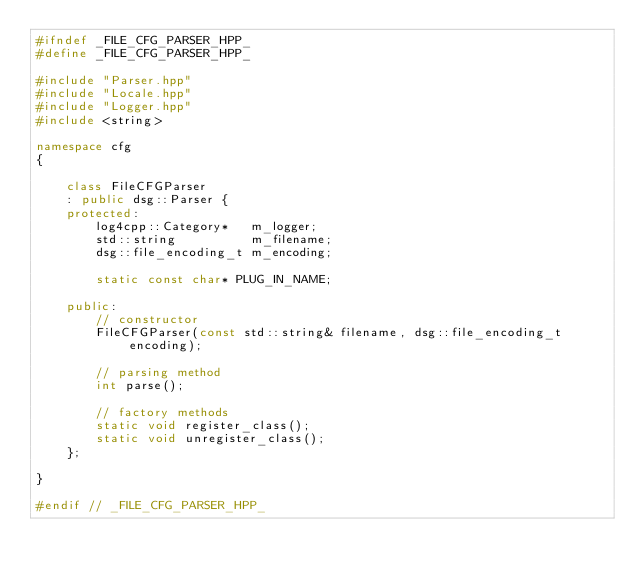<code> <loc_0><loc_0><loc_500><loc_500><_C++_>#ifndef _FILE_CFG_PARSER_HPP_
#define _FILE_CFG_PARSER_HPP_

#include "Parser.hpp"
#include "Locale.hpp"
#include "Logger.hpp"
#include <string>

namespace cfg
{

    class FileCFGParser
    : public dsg::Parser {
    protected:
        log4cpp::Category*   m_logger;
        std::string          m_filename;
        dsg::file_encoding_t m_encoding;

        static const char* PLUG_IN_NAME;

    public:
        // constructor
        FileCFGParser(const std::string& filename, dsg::file_encoding_t encoding);

        // parsing method
        int parse();

        // factory methods
        static void register_class();
        static void unregister_class();
    };

}

#endif // _FILE_CFG_PARSER_HPP_
</code> 